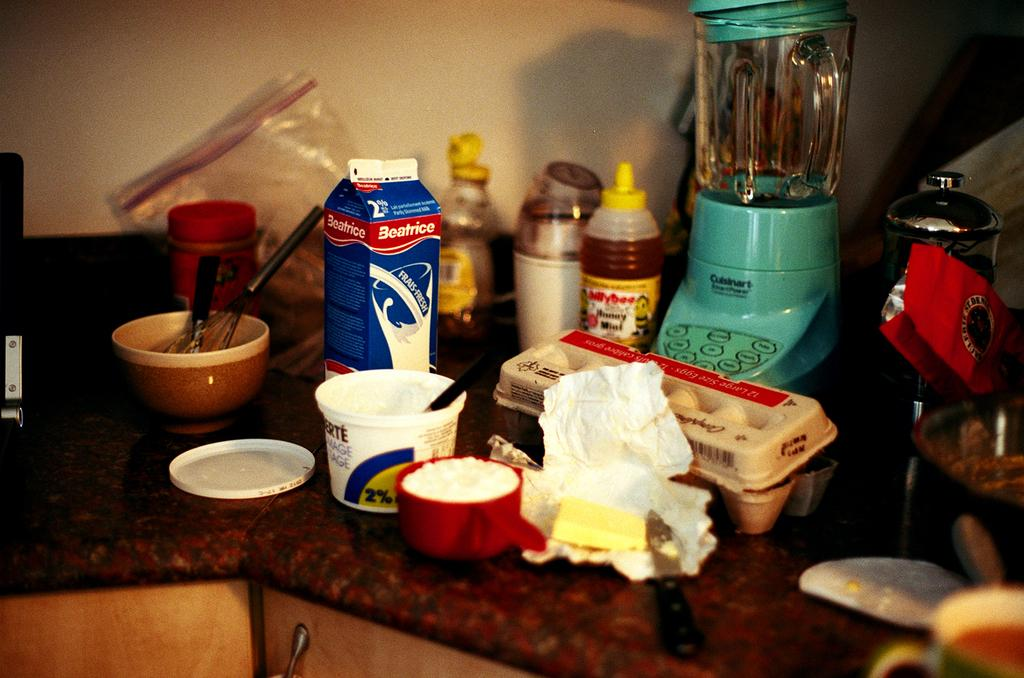<image>
Relay a brief, clear account of the picture shown. a kitchen counter has many things for cooking including Beatrice milk 